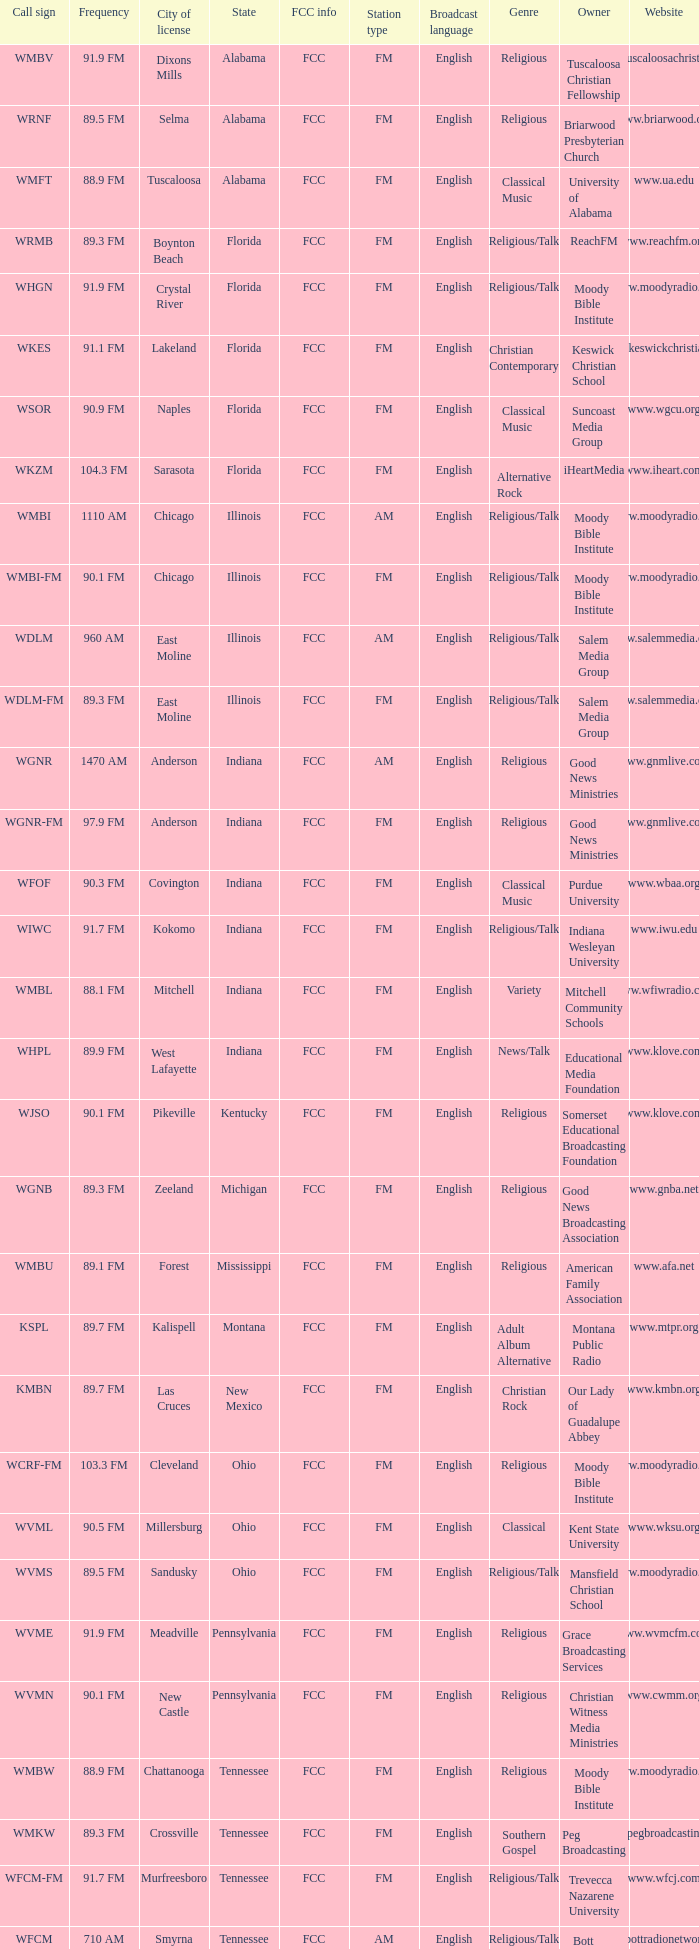What is the call sign for 90.9 FM which is in Florida? WSOR. 